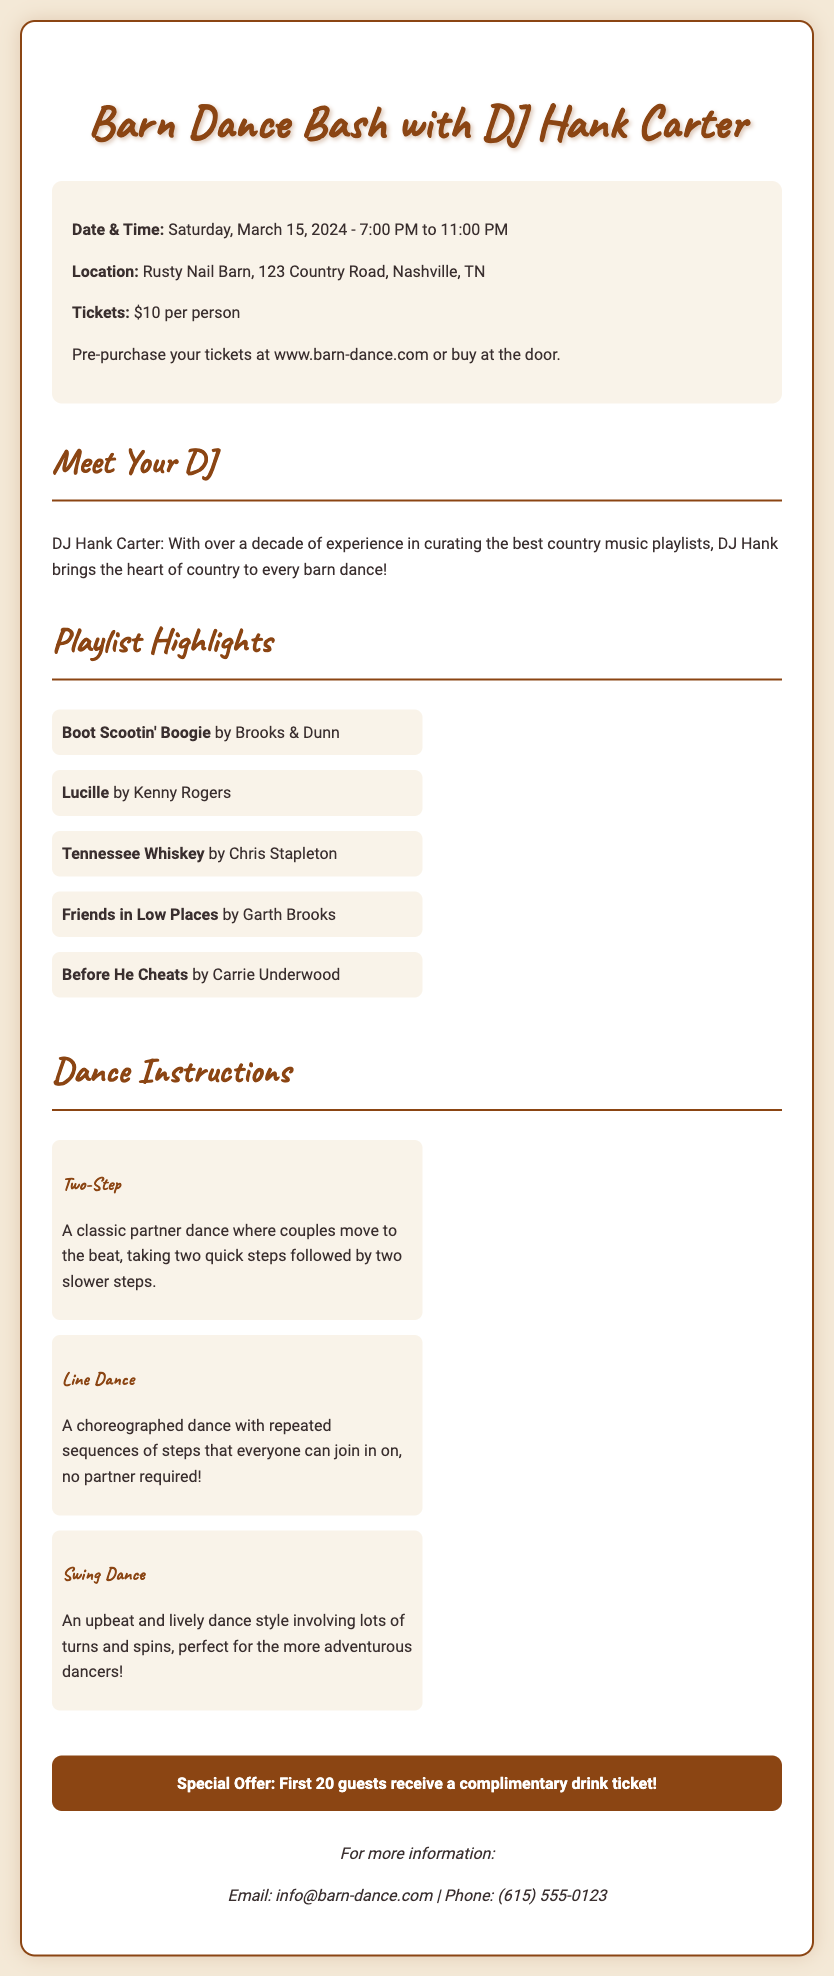What is the date of the barn dance event? The document specifies the date of the event as Saturday, March 15, 2024.
Answer: Saturday, March 15, 2024 What time does the barn dance start? According to the document, the barn dance starts at 7:00 PM.
Answer: 7:00 PM Who is the DJ for the event? The document mentions that DJ Hank Carter is the DJ for the event.
Answer: DJ Hank Carter How much is the ticket price? The ticket price is stated as $10 per person in the document.
Answer: $10 What is the location of the event? The document provides the location as Rusty Nail Barn, 123 Country Road, Nashville, TN.
Answer: Rusty Nail Barn, 123 Country Road, Nashville, TN What special offer is available for guests? The document states that the first 20 guests receive a complimentary drink ticket.
Answer: Complimentary drink ticket What type of dance is described as "an upbeat and lively dance style"? The document describes Swing Dance as "an upbeat and lively dance style."
Answer: Swing Dance How many songs are listed in the playlist highlights? The playlist highlights include five songs listed in the document.
Answer: Five What style of dance does not require a partner? The document explains that Line Dance does not require a partner.
Answer: Line Dance 